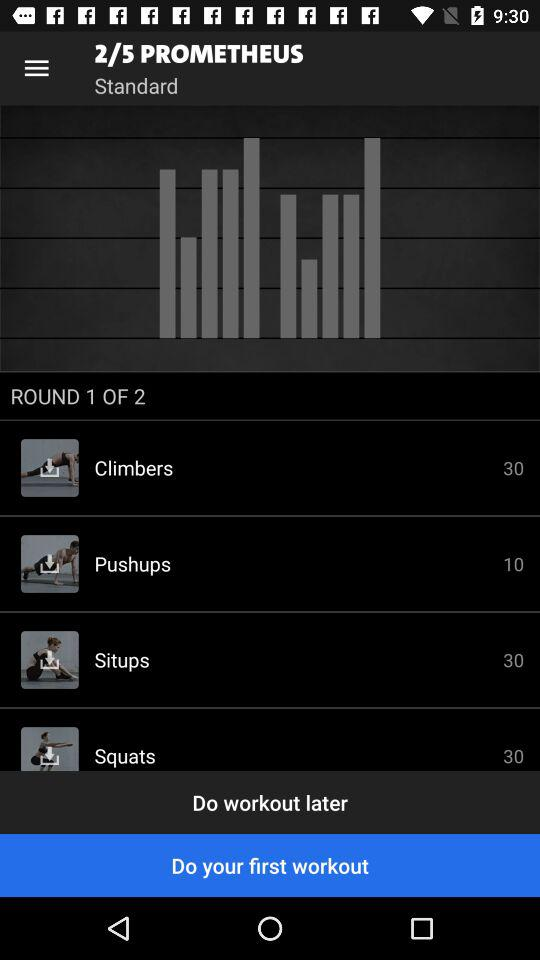What are the benefits of doing climbers, as displayed in the workout? Climbers, which are shown in the image with a rep count of 30, are excellent for building cardiovascular endurance and strengthening several muscle groups, including the core, hips, and shoulders. 